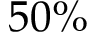Convert formula to latex. <formula><loc_0><loc_0><loc_500><loc_500>5 0 \%</formula> 